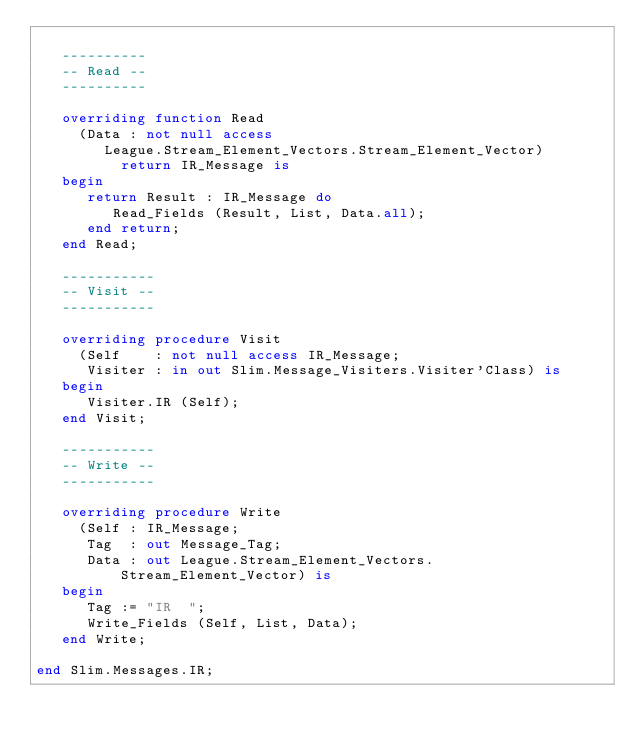Convert code to text. <code><loc_0><loc_0><loc_500><loc_500><_Ada_>
   ----------
   -- Read --
   ----------

   overriding function Read
     (Data : not null access
        League.Stream_Element_Vectors.Stream_Element_Vector)
          return IR_Message is
   begin
      return Result : IR_Message do
         Read_Fields (Result, List, Data.all);
      end return;
   end Read;

   -----------
   -- Visit --
   -----------

   overriding procedure Visit
     (Self    : not null access IR_Message;
      Visiter : in out Slim.Message_Visiters.Visiter'Class) is
   begin
      Visiter.IR (Self);
   end Visit;

   -----------
   -- Write --
   -----------

   overriding procedure Write
     (Self : IR_Message;
      Tag  : out Message_Tag;
      Data : out League.Stream_Element_Vectors.Stream_Element_Vector) is
   begin
      Tag := "IR  ";
      Write_Fields (Self, List, Data);
   end Write;

end Slim.Messages.IR;
</code> 